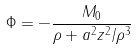<formula> <loc_0><loc_0><loc_500><loc_500>\Phi = - \frac { M _ { 0 } } { \rho + a ^ { 2 } z ^ { 2 } / \rho ^ { 3 } }</formula> 